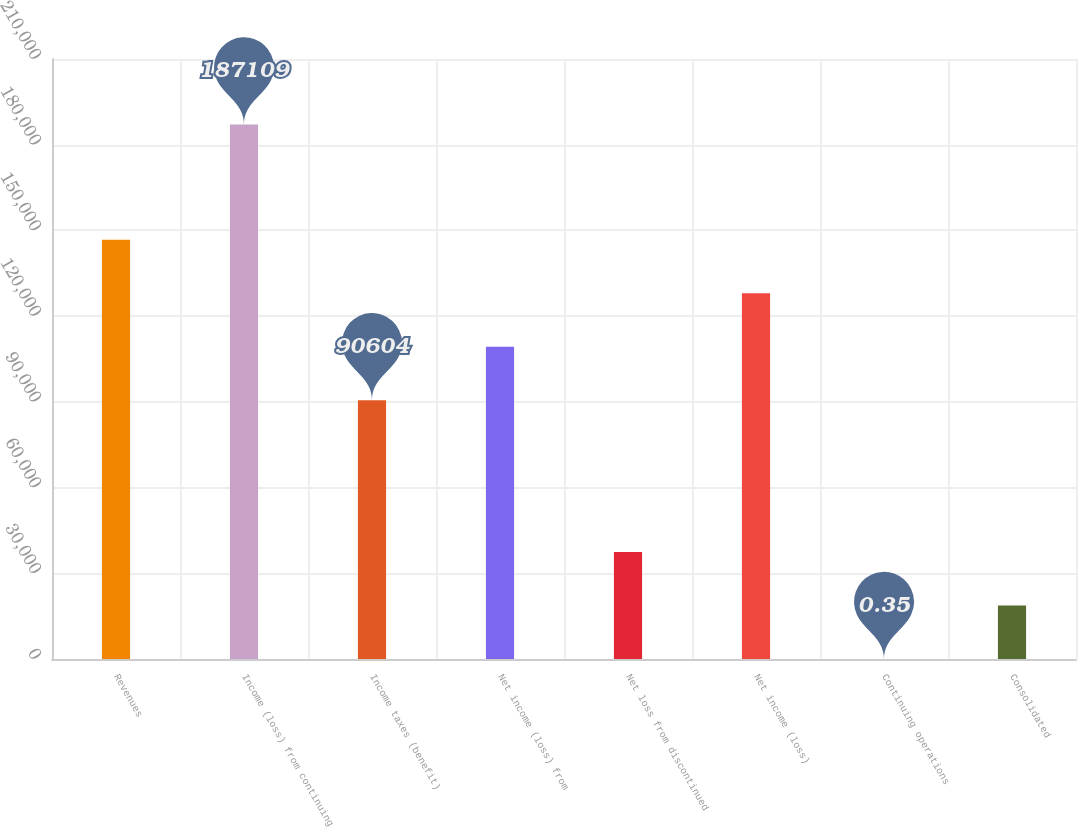Convert chart. <chart><loc_0><loc_0><loc_500><loc_500><bar_chart><fcel>Revenues<fcel>Income (loss) from continuing<fcel>Income taxes (benefit)<fcel>Net income (loss) from<fcel>Net loss from discontinued<fcel>Net income (loss)<fcel>Continuing operations<fcel>Consolidated<nl><fcel>146737<fcel>187109<fcel>90604<fcel>109315<fcel>37422.1<fcel>128026<fcel>0.35<fcel>18711.2<nl></chart> 